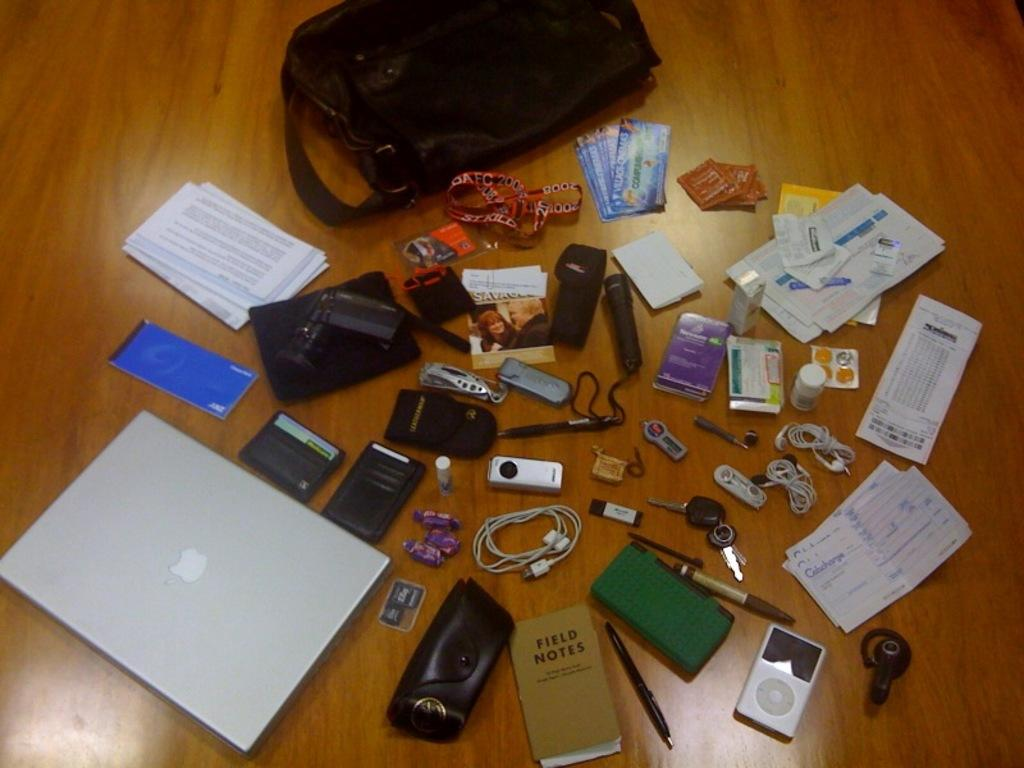What type of items can be seen in the image? There are electronic gadgets, papers, a backpack, notes, pens, key chains, pen-drives, and packets in the image. What objects are on a wooden object in the image? There are various objects on a wooden object in the image. What items might be used for writing or storing data? Pens, notes, and pen-drives might be used for writing or storing data. What can be used for carrying items in the image? A backpack can be used for carrying items in the image. How much wealth is represented by the underwear in the image? There is no underwear present in the image, so it is not possible to determine the amount of wealth represented. What type of slip can be seen on the wooden object in the image? There is no slip present on the wooden object in the image. 